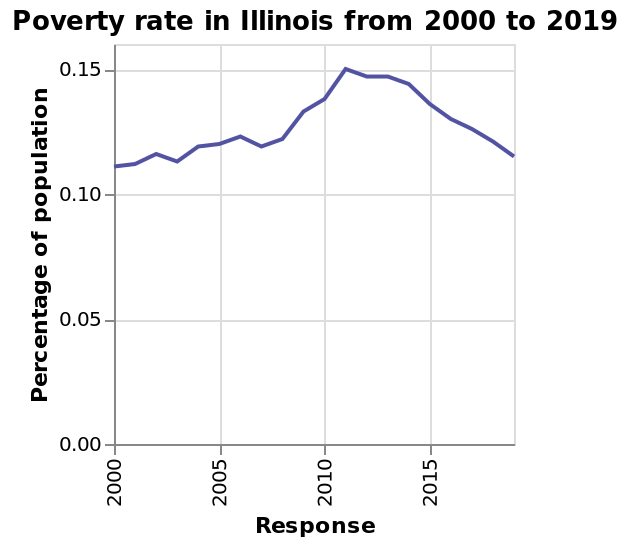<image>
please describe the details of the chart Here a line graph is titled Poverty rate in Illinois from 2000 to 2019. The x-axis measures Response. There is a scale from 0.00 to 0.15 along the y-axis, marked Percentage of population. What does the graph titled "Poverty rate in Illinois from 2000 to 2019" represent? The graph represents the poverty rate in Illinois over the years 2000 to 2019. How would you describe the trend of poverty rates from 2011 onwards? Poverty rates showed a declining trend from 2011 onwards, eventually stabilizing at previous levels. When did poverty reach its highest point? Poverty reached its highest point during 2011. please summary the statistics and relations of the chart The graph indicates that poverty peaked during 2011 before returning to previous stable poverty rates. 